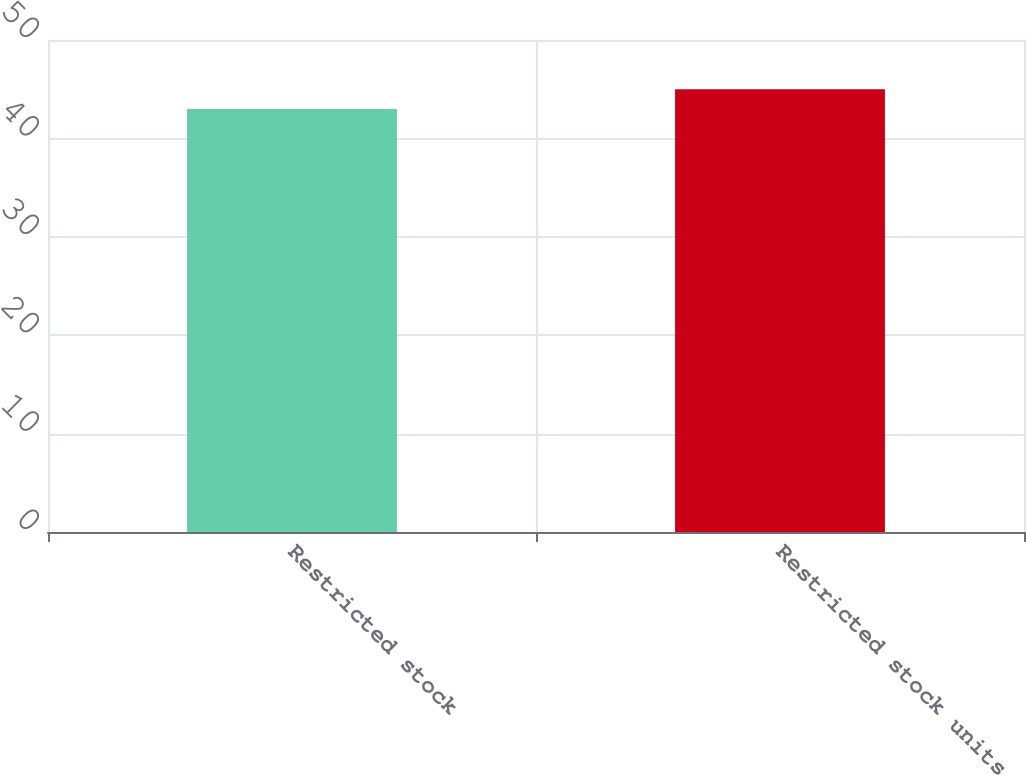Convert chart to OTSL. <chart><loc_0><loc_0><loc_500><loc_500><bar_chart><fcel>Restricted stock<fcel>Restricted stock units<nl><fcel>43<fcel>45<nl></chart> 